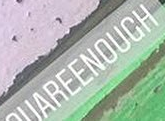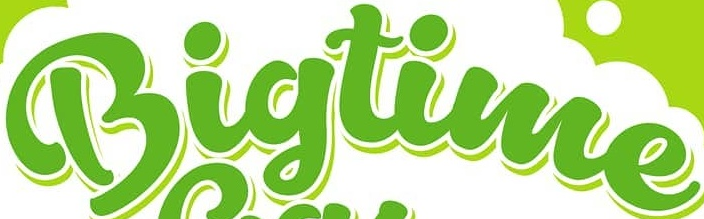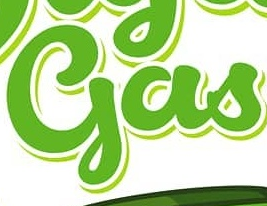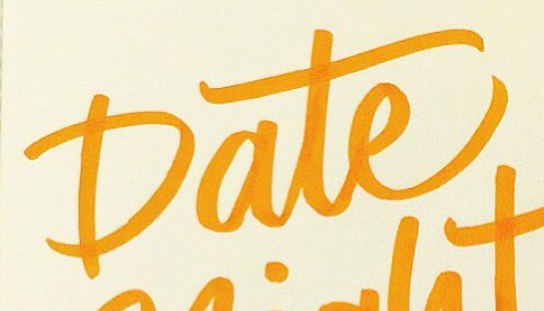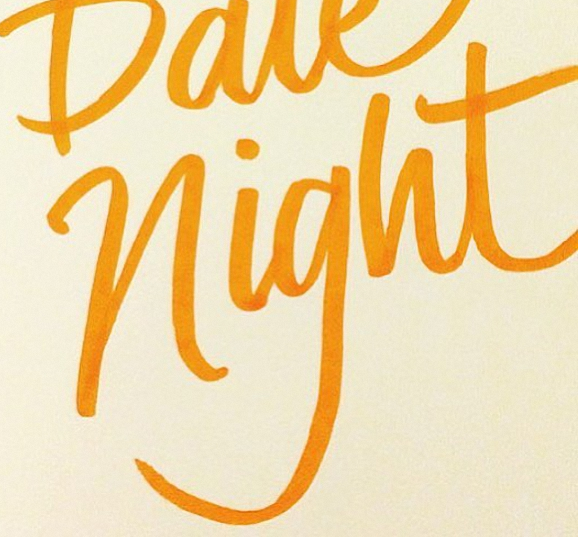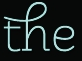What text appears in these images from left to right, separated by a semicolon? UAREENOUCH; Bigtime; gas; Date; night; the 